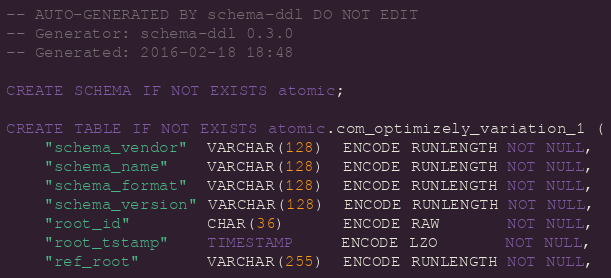<code> <loc_0><loc_0><loc_500><loc_500><_SQL_>-- AUTO-GENERATED BY schema-ddl DO NOT EDIT
-- Generator: schema-ddl 0.3.0
-- Generated: 2016-02-18 18:48

CREATE SCHEMA IF NOT EXISTS atomic;

CREATE TABLE IF NOT EXISTS atomic.com_optimizely_variation_1 (
    "schema_vendor"  VARCHAR(128)  ENCODE RUNLENGTH NOT NULL,
    "schema_name"    VARCHAR(128)  ENCODE RUNLENGTH NOT NULL,
    "schema_format"  VARCHAR(128)  ENCODE RUNLENGTH NOT NULL,
    "schema_version" VARCHAR(128)  ENCODE RUNLENGTH NOT NULL,
    "root_id"        CHAR(36)      ENCODE RAW       NOT NULL,
    "root_tstamp"    TIMESTAMP     ENCODE LZO       NOT NULL,
    "ref_root"       VARCHAR(255)  ENCODE RUNLENGTH NOT NULL,</code> 